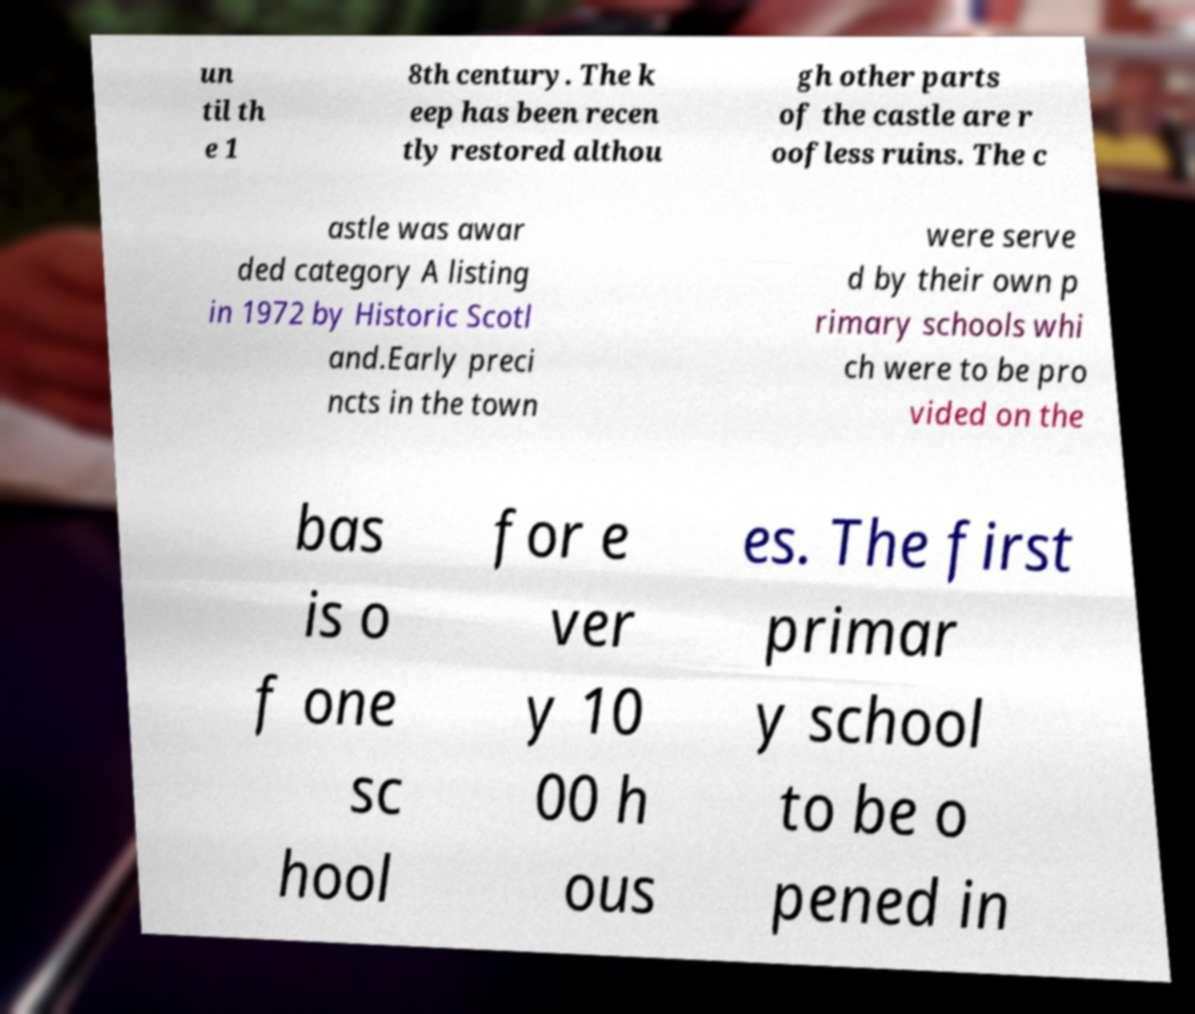For documentation purposes, I need the text within this image transcribed. Could you provide that? un til th e 1 8th century. The k eep has been recen tly restored althou gh other parts of the castle are r oofless ruins. The c astle was awar ded category A listing in 1972 by Historic Scotl and.Early preci ncts in the town were serve d by their own p rimary schools whi ch were to be pro vided on the bas is o f one sc hool for e ver y 10 00 h ous es. The first primar y school to be o pened in 